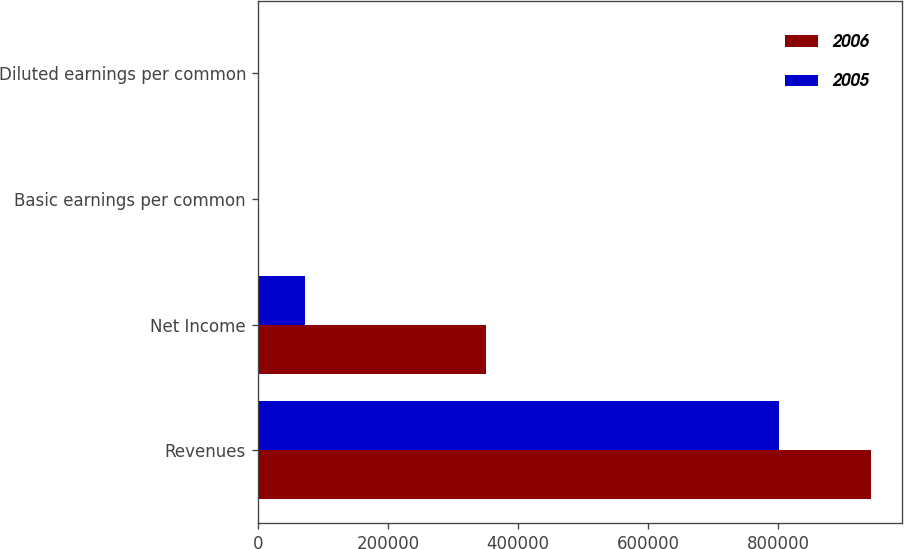<chart> <loc_0><loc_0><loc_500><loc_500><stacked_bar_chart><ecel><fcel>Revenues<fcel>Net Income<fcel>Basic earnings per common<fcel>Diluted earnings per common<nl><fcel>2006<fcel>943485<fcel>351239<fcel>1.95<fcel>1.94<nl><fcel>2005<fcel>801725<fcel>73364<fcel>0.32<fcel>0.32<nl></chart> 